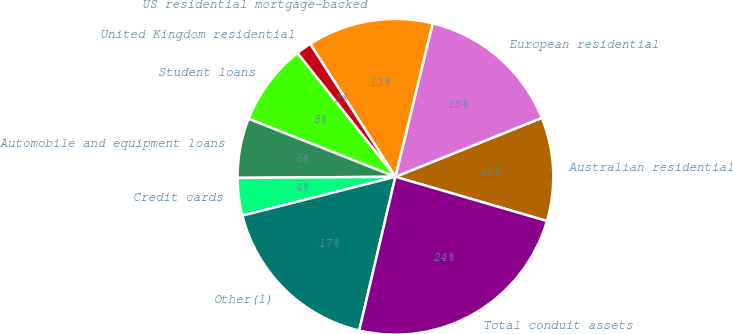Convert chart. <chart><loc_0><loc_0><loc_500><loc_500><pie_chart><fcel>Australian residential<fcel>European residential<fcel>US residential mortgage-backed<fcel>United Kingdom residential<fcel>Student loans<fcel>Automobile and equipment loans<fcel>Credit cards<fcel>Other(1)<fcel>Total conduit assets<nl><fcel>10.61%<fcel>15.12%<fcel>12.86%<fcel>1.59%<fcel>8.35%<fcel>6.1%<fcel>3.84%<fcel>17.37%<fcel>24.16%<nl></chart> 